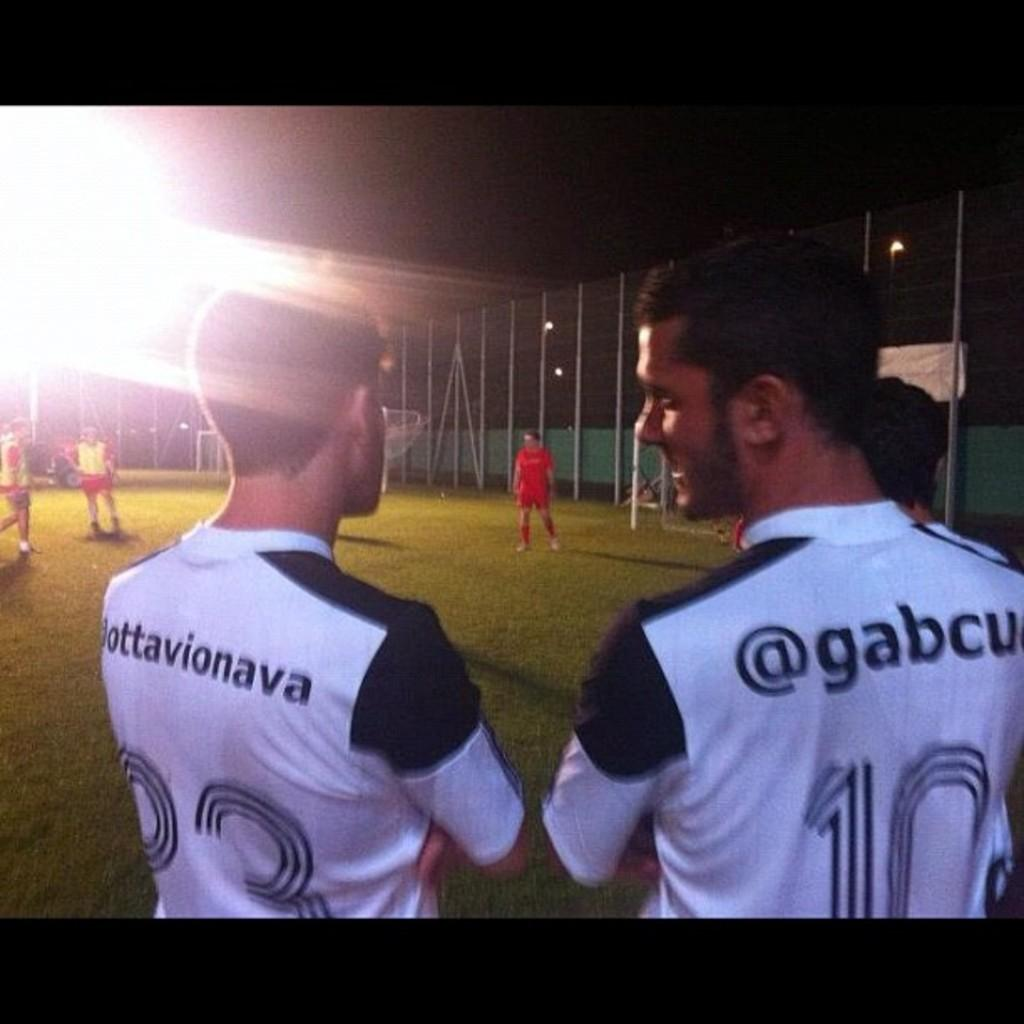<image>
Offer a succinct explanation of the picture presented. two soccer players with white jerseys with number 10 look out over a field 